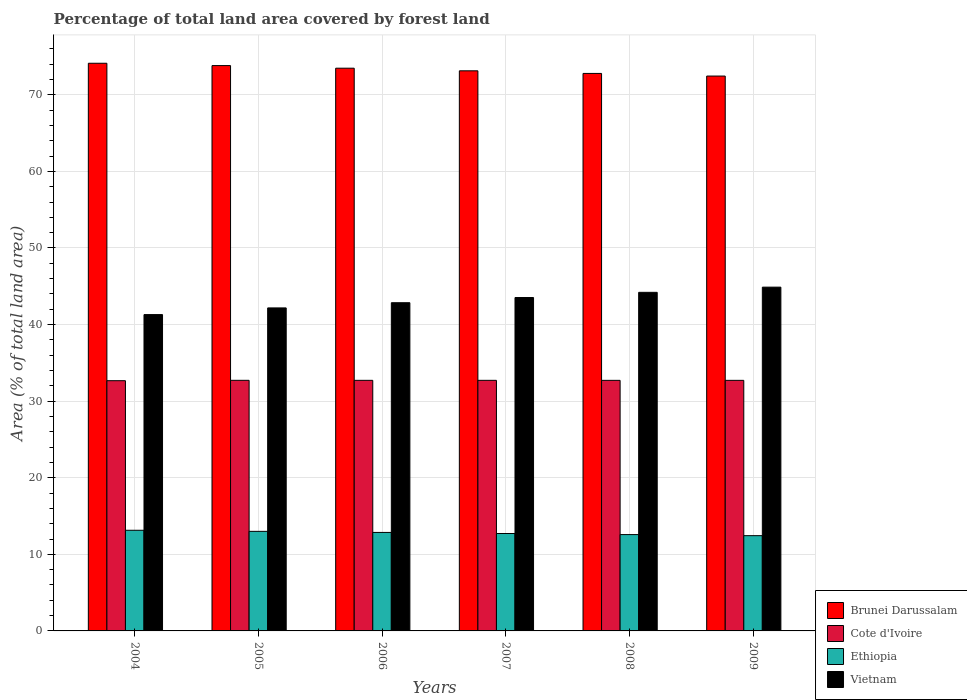How many different coloured bars are there?
Your response must be concise. 4. How many bars are there on the 1st tick from the left?
Offer a very short reply. 4. What is the label of the 6th group of bars from the left?
Provide a succinct answer. 2009. In how many cases, is the number of bars for a given year not equal to the number of legend labels?
Offer a terse response. 0. What is the percentage of forest land in Vietnam in 2005?
Ensure brevity in your answer.  42.17. Across all years, what is the maximum percentage of forest land in Vietnam?
Keep it short and to the point. 44.89. Across all years, what is the minimum percentage of forest land in Brunei Darussalam?
Your answer should be very brief. 72.45. In which year was the percentage of forest land in Vietnam maximum?
Your answer should be compact. 2009. What is the total percentage of forest land in Ethiopia in the graph?
Make the answer very short. 76.73. What is the difference between the percentage of forest land in Ethiopia in 2004 and that in 2007?
Your response must be concise. 0.42. What is the difference between the percentage of forest land in Ethiopia in 2008 and the percentage of forest land in Vietnam in 2006?
Give a very brief answer. -30.27. What is the average percentage of forest land in Ethiopia per year?
Your answer should be very brief. 12.79. In the year 2004, what is the difference between the percentage of forest land in Vietnam and percentage of forest land in Ethiopia?
Keep it short and to the point. 28.16. What is the ratio of the percentage of forest land in Vietnam in 2004 to that in 2006?
Your response must be concise. 0.96. What is the difference between the highest and the second highest percentage of forest land in Cote d'Ivoire?
Your answer should be compact. 0. What is the difference between the highest and the lowest percentage of forest land in Cote d'Ivoire?
Give a very brief answer. 0.05. In how many years, is the percentage of forest land in Cote d'Ivoire greater than the average percentage of forest land in Cote d'Ivoire taken over all years?
Offer a terse response. 5. What does the 2nd bar from the left in 2008 represents?
Keep it short and to the point. Cote d'Ivoire. What does the 2nd bar from the right in 2005 represents?
Provide a succinct answer. Ethiopia. Is it the case that in every year, the sum of the percentage of forest land in Vietnam and percentage of forest land in Ethiopia is greater than the percentage of forest land in Brunei Darussalam?
Offer a very short reply. No. Are all the bars in the graph horizontal?
Ensure brevity in your answer.  No. How many years are there in the graph?
Your response must be concise. 6. Does the graph contain any zero values?
Offer a terse response. No. Does the graph contain grids?
Ensure brevity in your answer.  Yes. What is the title of the graph?
Your response must be concise. Percentage of total land area covered by forest land. What is the label or title of the X-axis?
Your answer should be very brief. Years. What is the label or title of the Y-axis?
Your answer should be compact. Area (% of total land area). What is the Area (% of total land area) in Brunei Darussalam in 2004?
Offer a very short reply. 74.12. What is the Area (% of total land area) of Cote d'Ivoire in 2004?
Give a very brief answer. 32.67. What is the Area (% of total land area) of Ethiopia in 2004?
Your answer should be very brief. 13.14. What is the Area (% of total land area) of Vietnam in 2004?
Make the answer very short. 41.3. What is the Area (% of total land area) of Brunei Darussalam in 2005?
Give a very brief answer. 73.81. What is the Area (% of total land area) of Cote d'Ivoire in 2005?
Your response must be concise. 32.72. What is the Area (% of total land area) of Vietnam in 2005?
Your answer should be compact. 42.17. What is the Area (% of total land area) of Brunei Darussalam in 2006?
Your response must be concise. 73.47. What is the Area (% of total land area) of Cote d'Ivoire in 2006?
Ensure brevity in your answer.  32.72. What is the Area (% of total land area) of Ethiopia in 2006?
Offer a terse response. 12.86. What is the Area (% of total land area) of Vietnam in 2006?
Ensure brevity in your answer.  42.85. What is the Area (% of total land area) in Brunei Darussalam in 2007?
Make the answer very short. 73.13. What is the Area (% of total land area) in Cote d'Ivoire in 2007?
Provide a short and direct response. 32.72. What is the Area (% of total land area) of Ethiopia in 2007?
Ensure brevity in your answer.  12.72. What is the Area (% of total land area) in Vietnam in 2007?
Offer a terse response. 43.53. What is the Area (% of total land area) in Brunei Darussalam in 2008?
Give a very brief answer. 72.79. What is the Area (% of total land area) in Cote d'Ivoire in 2008?
Provide a succinct answer. 32.72. What is the Area (% of total land area) in Ethiopia in 2008?
Offer a very short reply. 12.58. What is the Area (% of total land area) of Vietnam in 2008?
Give a very brief answer. 44.21. What is the Area (% of total land area) in Brunei Darussalam in 2009?
Offer a very short reply. 72.45. What is the Area (% of total land area) of Cote d'Ivoire in 2009?
Keep it short and to the point. 32.72. What is the Area (% of total land area) of Ethiopia in 2009?
Make the answer very short. 12.44. What is the Area (% of total land area) in Vietnam in 2009?
Offer a very short reply. 44.89. Across all years, what is the maximum Area (% of total land area) in Brunei Darussalam?
Provide a succinct answer. 74.12. Across all years, what is the maximum Area (% of total land area) in Cote d'Ivoire?
Make the answer very short. 32.72. Across all years, what is the maximum Area (% of total land area) of Ethiopia?
Ensure brevity in your answer.  13.14. Across all years, what is the maximum Area (% of total land area) of Vietnam?
Your response must be concise. 44.89. Across all years, what is the minimum Area (% of total land area) in Brunei Darussalam?
Your response must be concise. 72.45. Across all years, what is the minimum Area (% of total land area) of Cote d'Ivoire?
Offer a terse response. 32.67. Across all years, what is the minimum Area (% of total land area) of Ethiopia?
Make the answer very short. 12.44. Across all years, what is the minimum Area (% of total land area) of Vietnam?
Offer a very short reply. 41.3. What is the total Area (% of total land area) in Brunei Darussalam in the graph?
Keep it short and to the point. 439.77. What is the total Area (% of total land area) in Cote d'Ivoire in the graph?
Offer a very short reply. 196.26. What is the total Area (% of total land area) of Ethiopia in the graph?
Make the answer very short. 76.73. What is the total Area (% of total land area) in Vietnam in the graph?
Offer a terse response. 258.95. What is the difference between the Area (% of total land area) in Brunei Darussalam in 2004 and that in 2005?
Provide a short and direct response. 0.3. What is the difference between the Area (% of total land area) in Cote d'Ivoire in 2004 and that in 2005?
Your response must be concise. -0.05. What is the difference between the Area (% of total land area) of Ethiopia in 2004 and that in 2005?
Your answer should be very brief. 0.14. What is the difference between the Area (% of total land area) of Vietnam in 2004 and that in 2005?
Keep it short and to the point. -0.87. What is the difference between the Area (% of total land area) of Brunei Darussalam in 2004 and that in 2006?
Your answer should be very brief. 0.65. What is the difference between the Area (% of total land area) of Cote d'Ivoire in 2004 and that in 2006?
Provide a succinct answer. -0.05. What is the difference between the Area (% of total land area) in Ethiopia in 2004 and that in 2006?
Your response must be concise. 0.28. What is the difference between the Area (% of total land area) of Vietnam in 2004 and that in 2006?
Offer a very short reply. -1.55. What is the difference between the Area (% of total land area) in Brunei Darussalam in 2004 and that in 2007?
Your response must be concise. 0.99. What is the difference between the Area (% of total land area) of Cote d'Ivoire in 2004 and that in 2007?
Your response must be concise. -0.05. What is the difference between the Area (% of total land area) in Ethiopia in 2004 and that in 2007?
Offer a very short reply. 0.42. What is the difference between the Area (% of total land area) in Vietnam in 2004 and that in 2007?
Offer a very short reply. -2.23. What is the difference between the Area (% of total land area) in Brunei Darussalam in 2004 and that in 2008?
Offer a very short reply. 1.33. What is the difference between the Area (% of total land area) in Cote d'Ivoire in 2004 and that in 2008?
Offer a terse response. -0.04. What is the difference between the Area (% of total land area) of Ethiopia in 2004 and that in 2008?
Offer a very short reply. 0.56. What is the difference between the Area (% of total land area) of Vietnam in 2004 and that in 2008?
Provide a succinct answer. -2.9. What is the difference between the Area (% of total land area) of Brunei Darussalam in 2004 and that in 2009?
Offer a terse response. 1.67. What is the difference between the Area (% of total land area) of Cote d'Ivoire in 2004 and that in 2009?
Provide a short and direct response. -0.04. What is the difference between the Area (% of total land area) in Ethiopia in 2004 and that in 2009?
Your response must be concise. 0.7. What is the difference between the Area (% of total land area) in Vietnam in 2004 and that in 2009?
Your response must be concise. -3.58. What is the difference between the Area (% of total land area) in Brunei Darussalam in 2005 and that in 2006?
Offer a very short reply. 0.34. What is the difference between the Area (% of total land area) of Cote d'Ivoire in 2005 and that in 2006?
Offer a very short reply. 0. What is the difference between the Area (% of total land area) in Ethiopia in 2005 and that in 2006?
Your answer should be compact. 0.14. What is the difference between the Area (% of total land area) in Vietnam in 2005 and that in 2006?
Your answer should be very brief. -0.68. What is the difference between the Area (% of total land area) of Brunei Darussalam in 2005 and that in 2007?
Make the answer very short. 0.68. What is the difference between the Area (% of total land area) in Cote d'Ivoire in 2005 and that in 2007?
Offer a terse response. 0. What is the difference between the Area (% of total land area) of Ethiopia in 2005 and that in 2007?
Keep it short and to the point. 0.28. What is the difference between the Area (% of total land area) of Vietnam in 2005 and that in 2007?
Make the answer very short. -1.36. What is the difference between the Area (% of total land area) of Brunei Darussalam in 2005 and that in 2008?
Provide a succinct answer. 1.02. What is the difference between the Area (% of total land area) in Cote d'Ivoire in 2005 and that in 2008?
Make the answer very short. 0. What is the difference between the Area (% of total land area) of Ethiopia in 2005 and that in 2008?
Provide a succinct answer. 0.42. What is the difference between the Area (% of total land area) of Vietnam in 2005 and that in 2008?
Offer a very short reply. -2.03. What is the difference between the Area (% of total land area) in Brunei Darussalam in 2005 and that in 2009?
Offer a terse response. 1.37. What is the difference between the Area (% of total land area) in Cote d'Ivoire in 2005 and that in 2009?
Your response must be concise. 0.01. What is the difference between the Area (% of total land area) of Ethiopia in 2005 and that in 2009?
Keep it short and to the point. 0.56. What is the difference between the Area (% of total land area) in Vietnam in 2005 and that in 2009?
Ensure brevity in your answer.  -2.71. What is the difference between the Area (% of total land area) in Brunei Darussalam in 2006 and that in 2007?
Provide a succinct answer. 0.34. What is the difference between the Area (% of total land area) of Cote d'Ivoire in 2006 and that in 2007?
Ensure brevity in your answer.  0. What is the difference between the Area (% of total land area) of Ethiopia in 2006 and that in 2007?
Provide a short and direct response. 0.14. What is the difference between the Area (% of total land area) in Vietnam in 2006 and that in 2007?
Give a very brief answer. -0.68. What is the difference between the Area (% of total land area) in Brunei Darussalam in 2006 and that in 2008?
Provide a short and direct response. 0.68. What is the difference between the Area (% of total land area) in Cote d'Ivoire in 2006 and that in 2008?
Your answer should be very brief. 0. What is the difference between the Area (% of total land area) in Ethiopia in 2006 and that in 2008?
Ensure brevity in your answer.  0.28. What is the difference between the Area (% of total land area) of Vietnam in 2006 and that in 2008?
Offer a very short reply. -1.36. What is the difference between the Area (% of total land area) of Brunei Darussalam in 2006 and that in 2009?
Make the answer very short. 1.02. What is the difference between the Area (% of total land area) in Cote d'Ivoire in 2006 and that in 2009?
Offer a very short reply. 0. What is the difference between the Area (% of total land area) in Ethiopia in 2006 and that in 2009?
Offer a terse response. 0.42. What is the difference between the Area (% of total land area) in Vietnam in 2006 and that in 2009?
Provide a short and direct response. -2.03. What is the difference between the Area (% of total land area) of Brunei Darussalam in 2007 and that in 2008?
Keep it short and to the point. 0.34. What is the difference between the Area (% of total land area) in Cote d'Ivoire in 2007 and that in 2008?
Give a very brief answer. 0. What is the difference between the Area (% of total land area) in Ethiopia in 2007 and that in 2008?
Give a very brief answer. 0.14. What is the difference between the Area (% of total land area) of Vietnam in 2007 and that in 2008?
Offer a very short reply. -0.68. What is the difference between the Area (% of total land area) of Brunei Darussalam in 2007 and that in 2009?
Provide a succinct answer. 0.68. What is the difference between the Area (% of total land area) of Cote d'Ivoire in 2007 and that in 2009?
Give a very brief answer. 0. What is the difference between the Area (% of total land area) in Ethiopia in 2007 and that in 2009?
Provide a short and direct response. 0.28. What is the difference between the Area (% of total land area) of Vietnam in 2007 and that in 2009?
Keep it short and to the point. -1.36. What is the difference between the Area (% of total land area) in Brunei Darussalam in 2008 and that in 2009?
Offer a very short reply. 0.34. What is the difference between the Area (% of total land area) of Cote d'Ivoire in 2008 and that in 2009?
Your response must be concise. 0. What is the difference between the Area (% of total land area) in Ethiopia in 2008 and that in 2009?
Give a very brief answer. 0.14. What is the difference between the Area (% of total land area) in Vietnam in 2008 and that in 2009?
Your response must be concise. -0.68. What is the difference between the Area (% of total land area) of Brunei Darussalam in 2004 and the Area (% of total land area) of Cote d'Ivoire in 2005?
Make the answer very short. 41.4. What is the difference between the Area (% of total land area) of Brunei Darussalam in 2004 and the Area (% of total land area) of Ethiopia in 2005?
Ensure brevity in your answer.  61.12. What is the difference between the Area (% of total land area) of Brunei Darussalam in 2004 and the Area (% of total land area) of Vietnam in 2005?
Your answer should be very brief. 31.94. What is the difference between the Area (% of total land area) of Cote d'Ivoire in 2004 and the Area (% of total land area) of Ethiopia in 2005?
Provide a succinct answer. 19.67. What is the difference between the Area (% of total land area) in Cote d'Ivoire in 2004 and the Area (% of total land area) in Vietnam in 2005?
Make the answer very short. -9.5. What is the difference between the Area (% of total land area) in Ethiopia in 2004 and the Area (% of total land area) in Vietnam in 2005?
Your answer should be compact. -29.03. What is the difference between the Area (% of total land area) of Brunei Darussalam in 2004 and the Area (% of total land area) of Cote d'Ivoire in 2006?
Your answer should be compact. 41.4. What is the difference between the Area (% of total land area) of Brunei Darussalam in 2004 and the Area (% of total land area) of Ethiopia in 2006?
Give a very brief answer. 61.26. What is the difference between the Area (% of total land area) of Brunei Darussalam in 2004 and the Area (% of total land area) of Vietnam in 2006?
Your answer should be compact. 31.27. What is the difference between the Area (% of total land area) in Cote d'Ivoire in 2004 and the Area (% of total land area) in Ethiopia in 2006?
Offer a very short reply. 19.81. What is the difference between the Area (% of total land area) of Cote d'Ivoire in 2004 and the Area (% of total land area) of Vietnam in 2006?
Your answer should be very brief. -10.18. What is the difference between the Area (% of total land area) in Ethiopia in 2004 and the Area (% of total land area) in Vietnam in 2006?
Make the answer very short. -29.71. What is the difference between the Area (% of total land area) in Brunei Darussalam in 2004 and the Area (% of total land area) in Cote d'Ivoire in 2007?
Give a very brief answer. 41.4. What is the difference between the Area (% of total land area) of Brunei Darussalam in 2004 and the Area (% of total land area) of Ethiopia in 2007?
Provide a succinct answer. 61.4. What is the difference between the Area (% of total land area) of Brunei Darussalam in 2004 and the Area (% of total land area) of Vietnam in 2007?
Your response must be concise. 30.59. What is the difference between the Area (% of total land area) in Cote d'Ivoire in 2004 and the Area (% of total land area) in Ethiopia in 2007?
Offer a terse response. 19.95. What is the difference between the Area (% of total land area) of Cote d'Ivoire in 2004 and the Area (% of total land area) of Vietnam in 2007?
Offer a terse response. -10.86. What is the difference between the Area (% of total land area) in Ethiopia in 2004 and the Area (% of total land area) in Vietnam in 2007?
Provide a succinct answer. -30.39. What is the difference between the Area (% of total land area) of Brunei Darussalam in 2004 and the Area (% of total land area) of Cote d'Ivoire in 2008?
Provide a short and direct response. 41.4. What is the difference between the Area (% of total land area) in Brunei Darussalam in 2004 and the Area (% of total land area) in Ethiopia in 2008?
Keep it short and to the point. 61.54. What is the difference between the Area (% of total land area) of Brunei Darussalam in 2004 and the Area (% of total land area) of Vietnam in 2008?
Provide a short and direct response. 29.91. What is the difference between the Area (% of total land area) in Cote d'Ivoire in 2004 and the Area (% of total land area) in Ethiopia in 2008?
Your answer should be compact. 20.09. What is the difference between the Area (% of total land area) of Cote d'Ivoire in 2004 and the Area (% of total land area) of Vietnam in 2008?
Provide a short and direct response. -11.54. What is the difference between the Area (% of total land area) in Ethiopia in 2004 and the Area (% of total land area) in Vietnam in 2008?
Keep it short and to the point. -31.07. What is the difference between the Area (% of total land area) in Brunei Darussalam in 2004 and the Area (% of total land area) in Cote d'Ivoire in 2009?
Provide a succinct answer. 41.4. What is the difference between the Area (% of total land area) in Brunei Darussalam in 2004 and the Area (% of total land area) in Ethiopia in 2009?
Keep it short and to the point. 61.68. What is the difference between the Area (% of total land area) of Brunei Darussalam in 2004 and the Area (% of total land area) of Vietnam in 2009?
Your answer should be compact. 29.23. What is the difference between the Area (% of total land area) of Cote d'Ivoire in 2004 and the Area (% of total land area) of Ethiopia in 2009?
Offer a terse response. 20.23. What is the difference between the Area (% of total land area) in Cote d'Ivoire in 2004 and the Area (% of total land area) in Vietnam in 2009?
Your response must be concise. -12.21. What is the difference between the Area (% of total land area) of Ethiopia in 2004 and the Area (% of total land area) of Vietnam in 2009?
Provide a short and direct response. -31.75. What is the difference between the Area (% of total land area) in Brunei Darussalam in 2005 and the Area (% of total land area) in Cote d'Ivoire in 2006?
Offer a terse response. 41.1. What is the difference between the Area (% of total land area) of Brunei Darussalam in 2005 and the Area (% of total land area) of Ethiopia in 2006?
Give a very brief answer. 60.95. What is the difference between the Area (% of total land area) of Brunei Darussalam in 2005 and the Area (% of total land area) of Vietnam in 2006?
Offer a very short reply. 30.96. What is the difference between the Area (% of total land area) of Cote d'Ivoire in 2005 and the Area (% of total land area) of Ethiopia in 2006?
Offer a very short reply. 19.86. What is the difference between the Area (% of total land area) in Cote d'Ivoire in 2005 and the Area (% of total land area) in Vietnam in 2006?
Offer a very short reply. -10.13. What is the difference between the Area (% of total land area) of Ethiopia in 2005 and the Area (% of total land area) of Vietnam in 2006?
Your answer should be very brief. -29.85. What is the difference between the Area (% of total land area) of Brunei Darussalam in 2005 and the Area (% of total land area) of Cote d'Ivoire in 2007?
Give a very brief answer. 41.1. What is the difference between the Area (% of total land area) of Brunei Darussalam in 2005 and the Area (% of total land area) of Ethiopia in 2007?
Offer a terse response. 61.1. What is the difference between the Area (% of total land area) of Brunei Darussalam in 2005 and the Area (% of total land area) of Vietnam in 2007?
Offer a terse response. 30.28. What is the difference between the Area (% of total land area) of Cote d'Ivoire in 2005 and the Area (% of total land area) of Ethiopia in 2007?
Your response must be concise. 20. What is the difference between the Area (% of total land area) of Cote d'Ivoire in 2005 and the Area (% of total land area) of Vietnam in 2007?
Your answer should be compact. -10.81. What is the difference between the Area (% of total land area) in Ethiopia in 2005 and the Area (% of total land area) in Vietnam in 2007?
Give a very brief answer. -30.53. What is the difference between the Area (% of total land area) in Brunei Darussalam in 2005 and the Area (% of total land area) in Cote d'Ivoire in 2008?
Offer a terse response. 41.1. What is the difference between the Area (% of total land area) in Brunei Darussalam in 2005 and the Area (% of total land area) in Ethiopia in 2008?
Your answer should be very brief. 61.24. What is the difference between the Area (% of total land area) of Brunei Darussalam in 2005 and the Area (% of total land area) of Vietnam in 2008?
Your answer should be very brief. 29.61. What is the difference between the Area (% of total land area) of Cote d'Ivoire in 2005 and the Area (% of total land area) of Ethiopia in 2008?
Your response must be concise. 20.14. What is the difference between the Area (% of total land area) in Cote d'Ivoire in 2005 and the Area (% of total land area) in Vietnam in 2008?
Ensure brevity in your answer.  -11.49. What is the difference between the Area (% of total land area) in Ethiopia in 2005 and the Area (% of total land area) in Vietnam in 2008?
Provide a succinct answer. -31.21. What is the difference between the Area (% of total land area) in Brunei Darussalam in 2005 and the Area (% of total land area) in Cote d'Ivoire in 2009?
Your response must be concise. 41.1. What is the difference between the Area (% of total land area) in Brunei Darussalam in 2005 and the Area (% of total land area) in Ethiopia in 2009?
Make the answer very short. 61.38. What is the difference between the Area (% of total land area) of Brunei Darussalam in 2005 and the Area (% of total land area) of Vietnam in 2009?
Give a very brief answer. 28.93. What is the difference between the Area (% of total land area) of Cote d'Ivoire in 2005 and the Area (% of total land area) of Ethiopia in 2009?
Provide a short and direct response. 20.28. What is the difference between the Area (% of total land area) of Cote d'Ivoire in 2005 and the Area (% of total land area) of Vietnam in 2009?
Your answer should be very brief. -12.17. What is the difference between the Area (% of total land area) in Ethiopia in 2005 and the Area (% of total land area) in Vietnam in 2009?
Your answer should be compact. -31.89. What is the difference between the Area (% of total land area) of Brunei Darussalam in 2006 and the Area (% of total land area) of Cote d'Ivoire in 2007?
Keep it short and to the point. 40.75. What is the difference between the Area (% of total land area) in Brunei Darussalam in 2006 and the Area (% of total land area) in Ethiopia in 2007?
Ensure brevity in your answer.  60.75. What is the difference between the Area (% of total land area) in Brunei Darussalam in 2006 and the Area (% of total land area) in Vietnam in 2007?
Keep it short and to the point. 29.94. What is the difference between the Area (% of total land area) of Cote d'Ivoire in 2006 and the Area (% of total land area) of Ethiopia in 2007?
Give a very brief answer. 20. What is the difference between the Area (% of total land area) of Cote d'Ivoire in 2006 and the Area (% of total land area) of Vietnam in 2007?
Provide a short and direct response. -10.81. What is the difference between the Area (% of total land area) of Ethiopia in 2006 and the Area (% of total land area) of Vietnam in 2007?
Your response must be concise. -30.67. What is the difference between the Area (% of total land area) in Brunei Darussalam in 2006 and the Area (% of total land area) in Cote d'Ivoire in 2008?
Provide a short and direct response. 40.76. What is the difference between the Area (% of total land area) of Brunei Darussalam in 2006 and the Area (% of total land area) of Ethiopia in 2008?
Your response must be concise. 60.89. What is the difference between the Area (% of total land area) of Brunei Darussalam in 2006 and the Area (% of total land area) of Vietnam in 2008?
Provide a short and direct response. 29.26. What is the difference between the Area (% of total land area) in Cote d'Ivoire in 2006 and the Area (% of total land area) in Ethiopia in 2008?
Offer a terse response. 20.14. What is the difference between the Area (% of total land area) of Cote d'Ivoire in 2006 and the Area (% of total land area) of Vietnam in 2008?
Your answer should be very brief. -11.49. What is the difference between the Area (% of total land area) of Ethiopia in 2006 and the Area (% of total land area) of Vietnam in 2008?
Keep it short and to the point. -31.35. What is the difference between the Area (% of total land area) in Brunei Darussalam in 2006 and the Area (% of total land area) in Cote d'Ivoire in 2009?
Give a very brief answer. 40.76. What is the difference between the Area (% of total land area) in Brunei Darussalam in 2006 and the Area (% of total land area) in Ethiopia in 2009?
Keep it short and to the point. 61.04. What is the difference between the Area (% of total land area) in Brunei Darussalam in 2006 and the Area (% of total land area) in Vietnam in 2009?
Make the answer very short. 28.59. What is the difference between the Area (% of total land area) of Cote d'Ivoire in 2006 and the Area (% of total land area) of Ethiopia in 2009?
Offer a very short reply. 20.28. What is the difference between the Area (% of total land area) of Cote d'Ivoire in 2006 and the Area (% of total land area) of Vietnam in 2009?
Provide a short and direct response. -12.17. What is the difference between the Area (% of total land area) in Ethiopia in 2006 and the Area (% of total land area) in Vietnam in 2009?
Make the answer very short. -32.03. What is the difference between the Area (% of total land area) of Brunei Darussalam in 2007 and the Area (% of total land area) of Cote d'Ivoire in 2008?
Provide a short and direct response. 40.41. What is the difference between the Area (% of total land area) of Brunei Darussalam in 2007 and the Area (% of total land area) of Ethiopia in 2008?
Your response must be concise. 60.55. What is the difference between the Area (% of total land area) of Brunei Darussalam in 2007 and the Area (% of total land area) of Vietnam in 2008?
Make the answer very short. 28.92. What is the difference between the Area (% of total land area) in Cote d'Ivoire in 2007 and the Area (% of total land area) in Ethiopia in 2008?
Your answer should be very brief. 20.14. What is the difference between the Area (% of total land area) in Cote d'Ivoire in 2007 and the Area (% of total land area) in Vietnam in 2008?
Offer a terse response. -11.49. What is the difference between the Area (% of total land area) in Ethiopia in 2007 and the Area (% of total land area) in Vietnam in 2008?
Your response must be concise. -31.49. What is the difference between the Area (% of total land area) in Brunei Darussalam in 2007 and the Area (% of total land area) in Cote d'Ivoire in 2009?
Keep it short and to the point. 40.42. What is the difference between the Area (% of total land area) of Brunei Darussalam in 2007 and the Area (% of total land area) of Ethiopia in 2009?
Ensure brevity in your answer.  60.69. What is the difference between the Area (% of total land area) in Brunei Darussalam in 2007 and the Area (% of total land area) in Vietnam in 2009?
Your response must be concise. 28.24. What is the difference between the Area (% of total land area) of Cote d'Ivoire in 2007 and the Area (% of total land area) of Ethiopia in 2009?
Provide a succinct answer. 20.28. What is the difference between the Area (% of total land area) of Cote d'Ivoire in 2007 and the Area (% of total land area) of Vietnam in 2009?
Your response must be concise. -12.17. What is the difference between the Area (% of total land area) of Ethiopia in 2007 and the Area (% of total land area) of Vietnam in 2009?
Make the answer very short. -32.17. What is the difference between the Area (% of total land area) in Brunei Darussalam in 2008 and the Area (% of total land area) in Cote d'Ivoire in 2009?
Offer a terse response. 40.07. What is the difference between the Area (% of total land area) in Brunei Darussalam in 2008 and the Area (% of total land area) in Ethiopia in 2009?
Offer a terse response. 60.35. What is the difference between the Area (% of total land area) of Brunei Darussalam in 2008 and the Area (% of total land area) of Vietnam in 2009?
Offer a terse response. 27.9. What is the difference between the Area (% of total land area) of Cote d'Ivoire in 2008 and the Area (% of total land area) of Ethiopia in 2009?
Ensure brevity in your answer.  20.28. What is the difference between the Area (% of total land area) of Cote d'Ivoire in 2008 and the Area (% of total land area) of Vietnam in 2009?
Make the answer very short. -12.17. What is the difference between the Area (% of total land area) of Ethiopia in 2008 and the Area (% of total land area) of Vietnam in 2009?
Make the answer very short. -32.31. What is the average Area (% of total land area) in Brunei Darussalam per year?
Provide a short and direct response. 73.3. What is the average Area (% of total land area) of Cote d'Ivoire per year?
Provide a succinct answer. 32.71. What is the average Area (% of total land area) of Ethiopia per year?
Provide a short and direct response. 12.79. What is the average Area (% of total land area) of Vietnam per year?
Keep it short and to the point. 43.16. In the year 2004, what is the difference between the Area (% of total land area) in Brunei Darussalam and Area (% of total land area) in Cote d'Ivoire?
Offer a very short reply. 41.45. In the year 2004, what is the difference between the Area (% of total land area) in Brunei Darussalam and Area (% of total land area) in Ethiopia?
Offer a very short reply. 60.98. In the year 2004, what is the difference between the Area (% of total land area) of Brunei Darussalam and Area (% of total land area) of Vietnam?
Your answer should be very brief. 32.81. In the year 2004, what is the difference between the Area (% of total land area) in Cote d'Ivoire and Area (% of total land area) in Ethiopia?
Make the answer very short. 19.53. In the year 2004, what is the difference between the Area (% of total land area) of Cote d'Ivoire and Area (% of total land area) of Vietnam?
Offer a very short reply. -8.63. In the year 2004, what is the difference between the Area (% of total land area) in Ethiopia and Area (% of total land area) in Vietnam?
Offer a very short reply. -28.16. In the year 2005, what is the difference between the Area (% of total land area) of Brunei Darussalam and Area (% of total land area) of Cote d'Ivoire?
Your answer should be compact. 41.09. In the year 2005, what is the difference between the Area (% of total land area) in Brunei Darussalam and Area (% of total land area) in Ethiopia?
Your response must be concise. 60.81. In the year 2005, what is the difference between the Area (% of total land area) of Brunei Darussalam and Area (% of total land area) of Vietnam?
Offer a terse response. 31.64. In the year 2005, what is the difference between the Area (% of total land area) in Cote d'Ivoire and Area (% of total land area) in Ethiopia?
Your response must be concise. 19.72. In the year 2005, what is the difference between the Area (% of total land area) in Cote d'Ivoire and Area (% of total land area) in Vietnam?
Offer a terse response. -9.45. In the year 2005, what is the difference between the Area (% of total land area) in Ethiopia and Area (% of total land area) in Vietnam?
Provide a short and direct response. -29.17. In the year 2006, what is the difference between the Area (% of total land area) of Brunei Darussalam and Area (% of total land area) of Cote d'Ivoire?
Give a very brief answer. 40.75. In the year 2006, what is the difference between the Area (% of total land area) in Brunei Darussalam and Area (% of total land area) in Ethiopia?
Your answer should be compact. 60.61. In the year 2006, what is the difference between the Area (% of total land area) in Brunei Darussalam and Area (% of total land area) in Vietnam?
Keep it short and to the point. 30.62. In the year 2006, what is the difference between the Area (% of total land area) of Cote d'Ivoire and Area (% of total land area) of Ethiopia?
Provide a succinct answer. 19.86. In the year 2006, what is the difference between the Area (% of total land area) of Cote d'Ivoire and Area (% of total land area) of Vietnam?
Provide a short and direct response. -10.13. In the year 2006, what is the difference between the Area (% of total land area) of Ethiopia and Area (% of total land area) of Vietnam?
Offer a terse response. -29.99. In the year 2007, what is the difference between the Area (% of total land area) of Brunei Darussalam and Area (% of total land area) of Cote d'Ivoire?
Make the answer very short. 40.41. In the year 2007, what is the difference between the Area (% of total land area) in Brunei Darussalam and Area (% of total land area) in Ethiopia?
Offer a very short reply. 60.41. In the year 2007, what is the difference between the Area (% of total land area) in Brunei Darussalam and Area (% of total land area) in Vietnam?
Offer a terse response. 29.6. In the year 2007, what is the difference between the Area (% of total land area) in Cote d'Ivoire and Area (% of total land area) in Ethiopia?
Provide a succinct answer. 20. In the year 2007, what is the difference between the Area (% of total land area) in Cote d'Ivoire and Area (% of total land area) in Vietnam?
Offer a very short reply. -10.81. In the year 2007, what is the difference between the Area (% of total land area) in Ethiopia and Area (% of total land area) in Vietnam?
Ensure brevity in your answer.  -30.81. In the year 2008, what is the difference between the Area (% of total land area) in Brunei Darussalam and Area (% of total land area) in Cote d'Ivoire?
Your answer should be very brief. 40.07. In the year 2008, what is the difference between the Area (% of total land area) of Brunei Darussalam and Area (% of total land area) of Ethiopia?
Give a very brief answer. 60.21. In the year 2008, what is the difference between the Area (% of total land area) of Brunei Darussalam and Area (% of total land area) of Vietnam?
Give a very brief answer. 28.58. In the year 2008, what is the difference between the Area (% of total land area) of Cote d'Ivoire and Area (% of total land area) of Ethiopia?
Keep it short and to the point. 20.14. In the year 2008, what is the difference between the Area (% of total land area) of Cote d'Ivoire and Area (% of total land area) of Vietnam?
Provide a short and direct response. -11.49. In the year 2008, what is the difference between the Area (% of total land area) of Ethiopia and Area (% of total land area) of Vietnam?
Your response must be concise. -31.63. In the year 2009, what is the difference between the Area (% of total land area) in Brunei Darussalam and Area (% of total land area) in Cote d'Ivoire?
Keep it short and to the point. 39.73. In the year 2009, what is the difference between the Area (% of total land area) in Brunei Darussalam and Area (% of total land area) in Ethiopia?
Provide a succinct answer. 60.01. In the year 2009, what is the difference between the Area (% of total land area) of Brunei Darussalam and Area (% of total land area) of Vietnam?
Keep it short and to the point. 27.56. In the year 2009, what is the difference between the Area (% of total land area) of Cote d'Ivoire and Area (% of total land area) of Ethiopia?
Your answer should be compact. 20.28. In the year 2009, what is the difference between the Area (% of total land area) of Cote d'Ivoire and Area (% of total land area) of Vietnam?
Keep it short and to the point. -12.17. In the year 2009, what is the difference between the Area (% of total land area) of Ethiopia and Area (% of total land area) of Vietnam?
Provide a succinct answer. -32.45. What is the ratio of the Area (% of total land area) of Brunei Darussalam in 2004 to that in 2005?
Provide a short and direct response. 1. What is the ratio of the Area (% of total land area) in Cote d'Ivoire in 2004 to that in 2005?
Ensure brevity in your answer.  1. What is the ratio of the Area (% of total land area) of Ethiopia in 2004 to that in 2005?
Your answer should be very brief. 1.01. What is the ratio of the Area (% of total land area) of Vietnam in 2004 to that in 2005?
Provide a short and direct response. 0.98. What is the ratio of the Area (% of total land area) in Brunei Darussalam in 2004 to that in 2006?
Your answer should be very brief. 1.01. What is the ratio of the Area (% of total land area) of Cote d'Ivoire in 2004 to that in 2006?
Give a very brief answer. 1. What is the ratio of the Area (% of total land area) of Ethiopia in 2004 to that in 2006?
Provide a succinct answer. 1.02. What is the ratio of the Area (% of total land area) in Vietnam in 2004 to that in 2006?
Your answer should be very brief. 0.96. What is the ratio of the Area (% of total land area) of Brunei Darussalam in 2004 to that in 2007?
Offer a very short reply. 1.01. What is the ratio of the Area (% of total land area) in Cote d'Ivoire in 2004 to that in 2007?
Give a very brief answer. 1. What is the ratio of the Area (% of total land area) of Ethiopia in 2004 to that in 2007?
Provide a succinct answer. 1.03. What is the ratio of the Area (% of total land area) of Vietnam in 2004 to that in 2007?
Offer a terse response. 0.95. What is the ratio of the Area (% of total land area) in Brunei Darussalam in 2004 to that in 2008?
Ensure brevity in your answer.  1.02. What is the ratio of the Area (% of total land area) of Cote d'Ivoire in 2004 to that in 2008?
Ensure brevity in your answer.  1. What is the ratio of the Area (% of total land area) in Ethiopia in 2004 to that in 2008?
Offer a terse response. 1.04. What is the ratio of the Area (% of total land area) of Vietnam in 2004 to that in 2008?
Provide a succinct answer. 0.93. What is the ratio of the Area (% of total land area) of Ethiopia in 2004 to that in 2009?
Give a very brief answer. 1.06. What is the ratio of the Area (% of total land area) of Vietnam in 2004 to that in 2009?
Your response must be concise. 0.92. What is the ratio of the Area (% of total land area) of Brunei Darussalam in 2005 to that in 2006?
Make the answer very short. 1. What is the ratio of the Area (% of total land area) in Cote d'Ivoire in 2005 to that in 2006?
Provide a short and direct response. 1. What is the ratio of the Area (% of total land area) of Ethiopia in 2005 to that in 2006?
Keep it short and to the point. 1.01. What is the ratio of the Area (% of total land area) in Vietnam in 2005 to that in 2006?
Offer a very short reply. 0.98. What is the ratio of the Area (% of total land area) of Brunei Darussalam in 2005 to that in 2007?
Your answer should be very brief. 1.01. What is the ratio of the Area (% of total land area) of Cote d'Ivoire in 2005 to that in 2007?
Offer a very short reply. 1. What is the ratio of the Area (% of total land area) in Ethiopia in 2005 to that in 2007?
Keep it short and to the point. 1.02. What is the ratio of the Area (% of total land area) in Vietnam in 2005 to that in 2007?
Offer a very short reply. 0.97. What is the ratio of the Area (% of total land area) in Brunei Darussalam in 2005 to that in 2008?
Offer a terse response. 1.01. What is the ratio of the Area (% of total land area) of Cote d'Ivoire in 2005 to that in 2008?
Make the answer very short. 1. What is the ratio of the Area (% of total land area) in Ethiopia in 2005 to that in 2008?
Make the answer very short. 1.03. What is the ratio of the Area (% of total land area) in Vietnam in 2005 to that in 2008?
Make the answer very short. 0.95. What is the ratio of the Area (% of total land area) in Brunei Darussalam in 2005 to that in 2009?
Make the answer very short. 1.02. What is the ratio of the Area (% of total land area) of Cote d'Ivoire in 2005 to that in 2009?
Your response must be concise. 1. What is the ratio of the Area (% of total land area) in Ethiopia in 2005 to that in 2009?
Give a very brief answer. 1.05. What is the ratio of the Area (% of total land area) of Vietnam in 2005 to that in 2009?
Your response must be concise. 0.94. What is the ratio of the Area (% of total land area) in Cote d'Ivoire in 2006 to that in 2007?
Your answer should be compact. 1. What is the ratio of the Area (% of total land area) of Ethiopia in 2006 to that in 2007?
Ensure brevity in your answer.  1.01. What is the ratio of the Area (% of total land area) in Vietnam in 2006 to that in 2007?
Ensure brevity in your answer.  0.98. What is the ratio of the Area (% of total land area) in Brunei Darussalam in 2006 to that in 2008?
Offer a very short reply. 1.01. What is the ratio of the Area (% of total land area) in Ethiopia in 2006 to that in 2008?
Offer a terse response. 1.02. What is the ratio of the Area (% of total land area) of Vietnam in 2006 to that in 2008?
Your answer should be very brief. 0.97. What is the ratio of the Area (% of total land area) of Brunei Darussalam in 2006 to that in 2009?
Offer a terse response. 1.01. What is the ratio of the Area (% of total land area) of Cote d'Ivoire in 2006 to that in 2009?
Your answer should be compact. 1. What is the ratio of the Area (% of total land area) of Ethiopia in 2006 to that in 2009?
Your answer should be compact. 1.03. What is the ratio of the Area (% of total land area) in Vietnam in 2006 to that in 2009?
Give a very brief answer. 0.95. What is the ratio of the Area (% of total land area) of Cote d'Ivoire in 2007 to that in 2008?
Offer a very short reply. 1. What is the ratio of the Area (% of total land area) in Ethiopia in 2007 to that in 2008?
Make the answer very short. 1.01. What is the ratio of the Area (% of total land area) in Vietnam in 2007 to that in 2008?
Provide a short and direct response. 0.98. What is the ratio of the Area (% of total land area) of Brunei Darussalam in 2007 to that in 2009?
Keep it short and to the point. 1.01. What is the ratio of the Area (% of total land area) of Ethiopia in 2007 to that in 2009?
Make the answer very short. 1.02. What is the ratio of the Area (% of total land area) of Vietnam in 2007 to that in 2009?
Provide a succinct answer. 0.97. What is the ratio of the Area (% of total land area) in Brunei Darussalam in 2008 to that in 2009?
Give a very brief answer. 1. What is the ratio of the Area (% of total land area) of Cote d'Ivoire in 2008 to that in 2009?
Offer a terse response. 1. What is the ratio of the Area (% of total land area) in Ethiopia in 2008 to that in 2009?
Provide a succinct answer. 1.01. What is the ratio of the Area (% of total land area) in Vietnam in 2008 to that in 2009?
Offer a very short reply. 0.98. What is the difference between the highest and the second highest Area (% of total land area) of Brunei Darussalam?
Make the answer very short. 0.3. What is the difference between the highest and the second highest Area (% of total land area) in Cote d'Ivoire?
Keep it short and to the point. 0. What is the difference between the highest and the second highest Area (% of total land area) in Ethiopia?
Your answer should be compact. 0.14. What is the difference between the highest and the second highest Area (% of total land area) of Vietnam?
Give a very brief answer. 0.68. What is the difference between the highest and the lowest Area (% of total land area) of Brunei Darussalam?
Provide a succinct answer. 1.67. What is the difference between the highest and the lowest Area (% of total land area) of Cote d'Ivoire?
Keep it short and to the point. 0.05. What is the difference between the highest and the lowest Area (% of total land area) in Ethiopia?
Offer a very short reply. 0.7. What is the difference between the highest and the lowest Area (% of total land area) in Vietnam?
Your answer should be very brief. 3.58. 